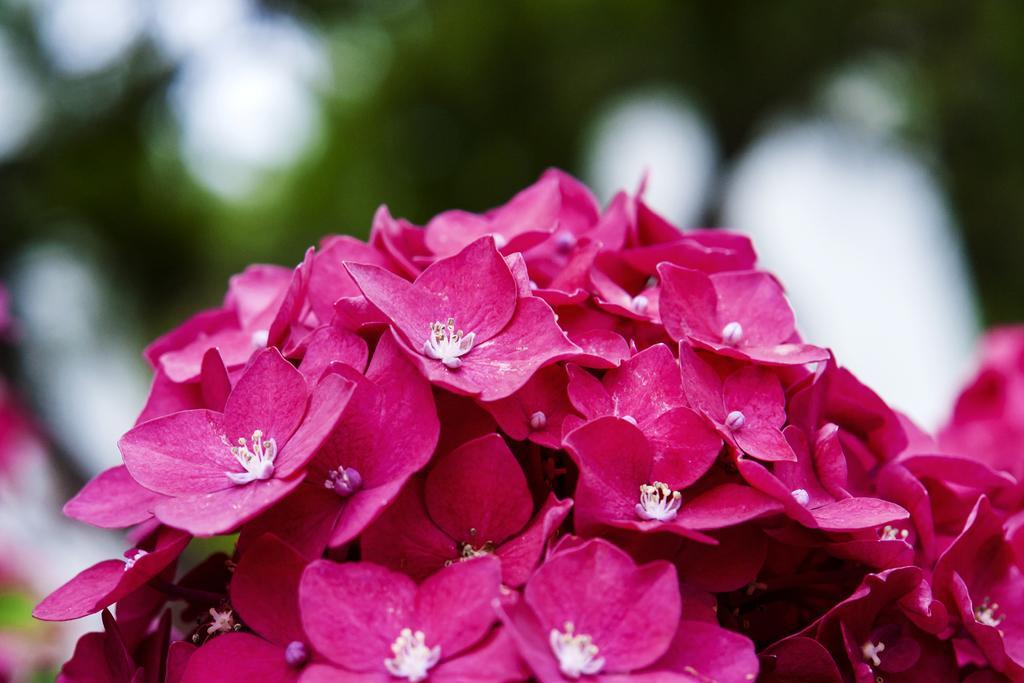In one or two sentences, can you explain what this image depicts? In this picture I can see there are a bunch of flowers and they are in pink color and the backdrop is blurred. 